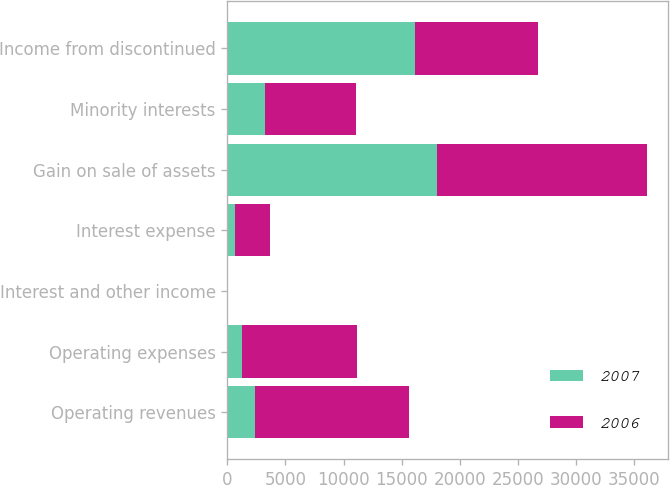Convert chart. <chart><loc_0><loc_0><loc_500><loc_500><stacked_bar_chart><ecel><fcel>Operating revenues<fcel>Operating expenses<fcel>Interest and other income<fcel>Interest expense<fcel>Gain on sale of assets<fcel>Minority interests<fcel>Income from discontinued<nl><fcel>2007<fcel>2340<fcel>1283<fcel>5<fcel>607<fcel>18049<fcel>3264<fcel>16180<nl><fcel>2006<fcel>13285<fcel>9915<fcel>20<fcel>3076<fcel>18096<fcel>7798<fcel>10612<nl></chart> 